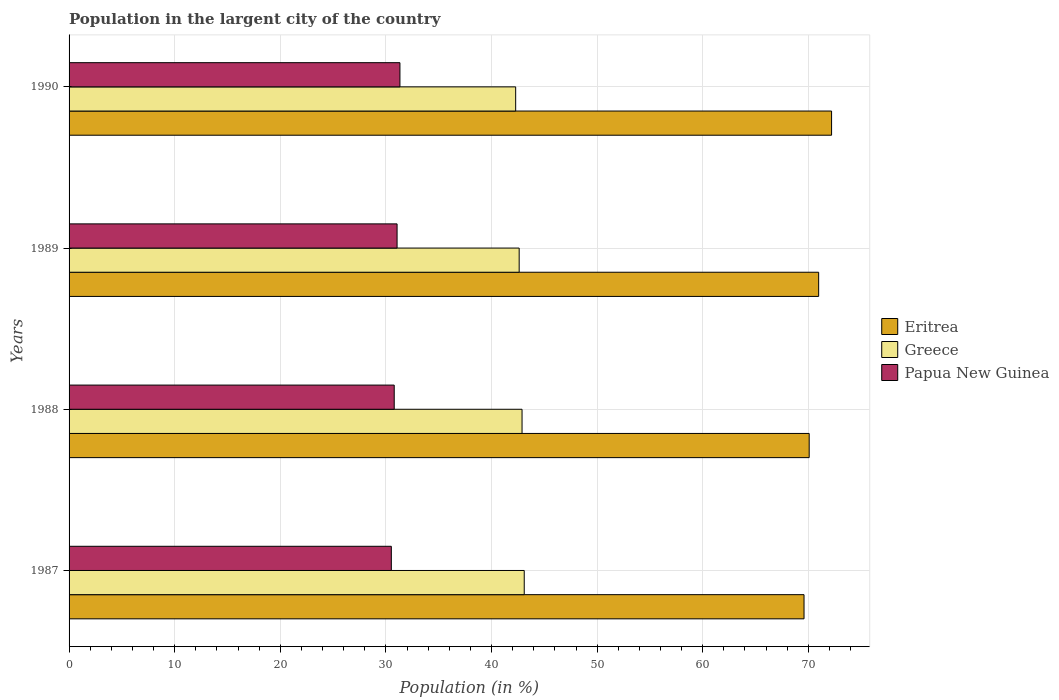How many different coloured bars are there?
Offer a terse response. 3. How many groups of bars are there?
Offer a very short reply. 4. Are the number of bars per tick equal to the number of legend labels?
Offer a very short reply. Yes. How many bars are there on the 4th tick from the top?
Keep it short and to the point. 3. How many bars are there on the 4th tick from the bottom?
Ensure brevity in your answer.  3. What is the label of the 3rd group of bars from the top?
Provide a short and direct response. 1988. In how many cases, is the number of bars for a given year not equal to the number of legend labels?
Give a very brief answer. 0. What is the percentage of population in the largent city in Papua New Guinea in 1987?
Provide a short and direct response. 30.51. Across all years, what is the maximum percentage of population in the largent city in Papua New Guinea?
Offer a terse response. 31.33. Across all years, what is the minimum percentage of population in the largent city in Greece?
Offer a very short reply. 42.29. In which year was the percentage of population in the largent city in Papua New Guinea maximum?
Your answer should be very brief. 1990. In which year was the percentage of population in the largent city in Eritrea minimum?
Keep it short and to the point. 1987. What is the total percentage of population in the largent city in Greece in the graph?
Your answer should be very brief. 170.9. What is the difference between the percentage of population in the largent city in Papua New Guinea in 1989 and that in 1990?
Make the answer very short. -0.27. What is the difference between the percentage of population in the largent city in Eritrea in 1990 and the percentage of population in the largent city in Greece in 1988?
Your answer should be very brief. 29.31. What is the average percentage of population in the largent city in Papua New Guinea per year?
Your answer should be compact. 30.92. In the year 1987, what is the difference between the percentage of population in the largent city in Eritrea and percentage of population in the largent city in Papua New Guinea?
Make the answer very short. 39.08. What is the ratio of the percentage of population in the largent city in Papua New Guinea in 1987 to that in 1988?
Keep it short and to the point. 0.99. What is the difference between the highest and the second highest percentage of population in the largent city in Greece?
Provide a short and direct response. 0.21. What is the difference between the highest and the lowest percentage of population in the largent city in Greece?
Your answer should be compact. 0.81. What does the 1st bar from the top in 1990 represents?
Make the answer very short. Papua New Guinea. What does the 3rd bar from the bottom in 1987 represents?
Ensure brevity in your answer.  Papua New Guinea. How many bars are there?
Your answer should be compact. 12. What is the difference between two consecutive major ticks on the X-axis?
Give a very brief answer. 10. Where does the legend appear in the graph?
Offer a terse response. Center right. How are the legend labels stacked?
Make the answer very short. Vertical. What is the title of the graph?
Provide a succinct answer. Population in the largent city of the country. Does "Mexico" appear as one of the legend labels in the graph?
Your answer should be very brief. No. What is the label or title of the X-axis?
Keep it short and to the point. Population (in %). What is the label or title of the Y-axis?
Your answer should be very brief. Years. What is the Population (in %) in Eritrea in 1987?
Ensure brevity in your answer.  69.59. What is the Population (in %) in Greece in 1987?
Keep it short and to the point. 43.1. What is the Population (in %) of Papua New Guinea in 1987?
Offer a very short reply. 30.51. What is the Population (in %) of Eritrea in 1988?
Give a very brief answer. 70.08. What is the Population (in %) of Greece in 1988?
Offer a very short reply. 42.89. What is the Population (in %) in Papua New Guinea in 1988?
Your response must be concise. 30.79. What is the Population (in %) of Eritrea in 1989?
Give a very brief answer. 70.98. What is the Population (in %) in Greece in 1989?
Your answer should be compact. 42.62. What is the Population (in %) in Papua New Guinea in 1989?
Offer a very short reply. 31.06. What is the Population (in %) in Eritrea in 1990?
Ensure brevity in your answer.  72.2. What is the Population (in %) in Greece in 1990?
Your answer should be compact. 42.29. What is the Population (in %) of Papua New Guinea in 1990?
Offer a very short reply. 31.33. Across all years, what is the maximum Population (in %) of Eritrea?
Make the answer very short. 72.2. Across all years, what is the maximum Population (in %) in Greece?
Ensure brevity in your answer.  43.1. Across all years, what is the maximum Population (in %) of Papua New Guinea?
Offer a terse response. 31.33. Across all years, what is the minimum Population (in %) of Eritrea?
Your answer should be very brief. 69.59. Across all years, what is the minimum Population (in %) of Greece?
Keep it short and to the point. 42.29. Across all years, what is the minimum Population (in %) of Papua New Guinea?
Give a very brief answer. 30.51. What is the total Population (in %) of Eritrea in the graph?
Provide a succinct answer. 282.85. What is the total Population (in %) of Greece in the graph?
Your response must be concise. 170.9. What is the total Population (in %) of Papua New Guinea in the graph?
Provide a short and direct response. 123.69. What is the difference between the Population (in %) in Eritrea in 1987 and that in 1988?
Your response must be concise. -0.49. What is the difference between the Population (in %) of Greece in 1987 and that in 1988?
Provide a succinct answer. 0.21. What is the difference between the Population (in %) of Papua New Guinea in 1987 and that in 1988?
Make the answer very short. -0.27. What is the difference between the Population (in %) of Eritrea in 1987 and that in 1989?
Give a very brief answer. -1.39. What is the difference between the Population (in %) in Greece in 1987 and that in 1989?
Your response must be concise. 0.48. What is the difference between the Population (in %) in Papua New Guinea in 1987 and that in 1989?
Provide a short and direct response. -0.54. What is the difference between the Population (in %) of Eritrea in 1987 and that in 1990?
Offer a very short reply. -2.61. What is the difference between the Population (in %) in Greece in 1987 and that in 1990?
Your answer should be very brief. 0.81. What is the difference between the Population (in %) in Papua New Guinea in 1987 and that in 1990?
Your response must be concise. -0.81. What is the difference between the Population (in %) in Eritrea in 1988 and that in 1989?
Keep it short and to the point. -0.9. What is the difference between the Population (in %) of Greece in 1988 and that in 1989?
Offer a terse response. 0.27. What is the difference between the Population (in %) in Papua New Guinea in 1988 and that in 1989?
Offer a terse response. -0.27. What is the difference between the Population (in %) in Eritrea in 1988 and that in 1990?
Provide a succinct answer. -2.12. What is the difference between the Population (in %) in Greece in 1988 and that in 1990?
Give a very brief answer. 0.6. What is the difference between the Population (in %) in Papua New Guinea in 1988 and that in 1990?
Ensure brevity in your answer.  -0.54. What is the difference between the Population (in %) in Eritrea in 1989 and that in 1990?
Make the answer very short. -1.22. What is the difference between the Population (in %) in Greece in 1989 and that in 1990?
Offer a very short reply. 0.33. What is the difference between the Population (in %) in Papua New Guinea in 1989 and that in 1990?
Offer a very short reply. -0.27. What is the difference between the Population (in %) in Eritrea in 1987 and the Population (in %) in Greece in 1988?
Your response must be concise. 26.7. What is the difference between the Population (in %) in Eritrea in 1987 and the Population (in %) in Papua New Guinea in 1988?
Your answer should be very brief. 38.8. What is the difference between the Population (in %) of Greece in 1987 and the Population (in %) of Papua New Guinea in 1988?
Ensure brevity in your answer.  12.31. What is the difference between the Population (in %) of Eritrea in 1987 and the Population (in %) of Greece in 1989?
Make the answer very short. 26.97. What is the difference between the Population (in %) of Eritrea in 1987 and the Population (in %) of Papua New Guinea in 1989?
Ensure brevity in your answer.  38.53. What is the difference between the Population (in %) of Greece in 1987 and the Population (in %) of Papua New Guinea in 1989?
Offer a terse response. 12.04. What is the difference between the Population (in %) in Eritrea in 1987 and the Population (in %) in Greece in 1990?
Offer a very short reply. 27.3. What is the difference between the Population (in %) of Eritrea in 1987 and the Population (in %) of Papua New Guinea in 1990?
Provide a short and direct response. 38.26. What is the difference between the Population (in %) in Greece in 1987 and the Population (in %) in Papua New Guinea in 1990?
Make the answer very short. 11.77. What is the difference between the Population (in %) in Eritrea in 1988 and the Population (in %) in Greece in 1989?
Your response must be concise. 27.46. What is the difference between the Population (in %) of Eritrea in 1988 and the Population (in %) of Papua New Guinea in 1989?
Your response must be concise. 39.02. What is the difference between the Population (in %) in Greece in 1988 and the Population (in %) in Papua New Guinea in 1989?
Give a very brief answer. 11.83. What is the difference between the Population (in %) in Eritrea in 1988 and the Population (in %) in Greece in 1990?
Offer a very short reply. 27.79. What is the difference between the Population (in %) of Eritrea in 1988 and the Population (in %) of Papua New Guinea in 1990?
Give a very brief answer. 38.75. What is the difference between the Population (in %) in Greece in 1988 and the Population (in %) in Papua New Guinea in 1990?
Give a very brief answer. 11.56. What is the difference between the Population (in %) of Eritrea in 1989 and the Population (in %) of Greece in 1990?
Make the answer very short. 28.69. What is the difference between the Population (in %) in Eritrea in 1989 and the Population (in %) in Papua New Guinea in 1990?
Offer a very short reply. 39.65. What is the difference between the Population (in %) of Greece in 1989 and the Population (in %) of Papua New Guinea in 1990?
Offer a terse response. 11.29. What is the average Population (in %) in Eritrea per year?
Keep it short and to the point. 70.71. What is the average Population (in %) of Greece per year?
Your answer should be compact. 42.72. What is the average Population (in %) of Papua New Guinea per year?
Make the answer very short. 30.92. In the year 1987, what is the difference between the Population (in %) in Eritrea and Population (in %) in Greece?
Your answer should be compact. 26.49. In the year 1987, what is the difference between the Population (in %) in Eritrea and Population (in %) in Papua New Guinea?
Make the answer very short. 39.08. In the year 1987, what is the difference between the Population (in %) in Greece and Population (in %) in Papua New Guinea?
Keep it short and to the point. 12.58. In the year 1988, what is the difference between the Population (in %) in Eritrea and Population (in %) in Greece?
Provide a succinct answer. 27.19. In the year 1988, what is the difference between the Population (in %) in Eritrea and Population (in %) in Papua New Guinea?
Ensure brevity in your answer.  39.29. In the year 1988, what is the difference between the Population (in %) in Greece and Population (in %) in Papua New Guinea?
Make the answer very short. 12.1. In the year 1989, what is the difference between the Population (in %) in Eritrea and Population (in %) in Greece?
Give a very brief answer. 28.36. In the year 1989, what is the difference between the Population (in %) in Eritrea and Population (in %) in Papua New Guinea?
Make the answer very short. 39.92. In the year 1989, what is the difference between the Population (in %) in Greece and Population (in %) in Papua New Guinea?
Keep it short and to the point. 11.56. In the year 1990, what is the difference between the Population (in %) in Eritrea and Population (in %) in Greece?
Offer a terse response. 29.91. In the year 1990, what is the difference between the Population (in %) of Eritrea and Population (in %) of Papua New Guinea?
Your answer should be very brief. 40.87. In the year 1990, what is the difference between the Population (in %) in Greece and Population (in %) in Papua New Guinea?
Ensure brevity in your answer.  10.96. What is the ratio of the Population (in %) of Greece in 1987 to that in 1988?
Keep it short and to the point. 1. What is the ratio of the Population (in %) in Papua New Guinea in 1987 to that in 1988?
Your response must be concise. 0.99. What is the ratio of the Population (in %) in Eritrea in 1987 to that in 1989?
Offer a very short reply. 0.98. What is the ratio of the Population (in %) of Greece in 1987 to that in 1989?
Give a very brief answer. 1.01. What is the ratio of the Population (in %) of Papua New Guinea in 1987 to that in 1989?
Ensure brevity in your answer.  0.98. What is the ratio of the Population (in %) in Eritrea in 1987 to that in 1990?
Your answer should be compact. 0.96. What is the ratio of the Population (in %) of Greece in 1987 to that in 1990?
Your answer should be compact. 1.02. What is the ratio of the Population (in %) of Papua New Guinea in 1987 to that in 1990?
Your response must be concise. 0.97. What is the ratio of the Population (in %) of Eritrea in 1988 to that in 1989?
Keep it short and to the point. 0.99. What is the ratio of the Population (in %) in Greece in 1988 to that in 1989?
Provide a succinct answer. 1.01. What is the ratio of the Population (in %) in Eritrea in 1988 to that in 1990?
Ensure brevity in your answer.  0.97. What is the ratio of the Population (in %) in Greece in 1988 to that in 1990?
Ensure brevity in your answer.  1.01. What is the ratio of the Population (in %) of Papua New Guinea in 1988 to that in 1990?
Offer a terse response. 0.98. What is the ratio of the Population (in %) of Eritrea in 1989 to that in 1990?
Offer a terse response. 0.98. What is the difference between the highest and the second highest Population (in %) of Eritrea?
Make the answer very short. 1.22. What is the difference between the highest and the second highest Population (in %) of Greece?
Provide a succinct answer. 0.21. What is the difference between the highest and the second highest Population (in %) of Papua New Guinea?
Keep it short and to the point. 0.27. What is the difference between the highest and the lowest Population (in %) of Eritrea?
Provide a succinct answer. 2.61. What is the difference between the highest and the lowest Population (in %) in Greece?
Offer a very short reply. 0.81. What is the difference between the highest and the lowest Population (in %) of Papua New Guinea?
Provide a succinct answer. 0.81. 